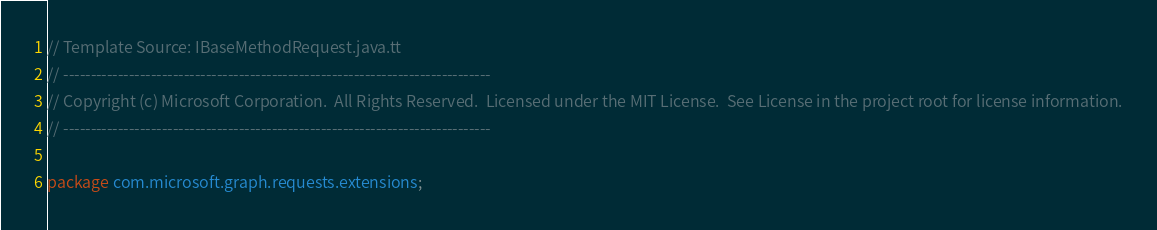<code> <loc_0><loc_0><loc_500><loc_500><_Java_>// Template Source: IBaseMethodRequest.java.tt
// ------------------------------------------------------------------------------
// Copyright (c) Microsoft Corporation.  All Rights Reserved.  Licensed under the MIT License.  See License in the project root for license information.
// ------------------------------------------------------------------------------

package com.microsoft.graph.requests.extensions;</code> 